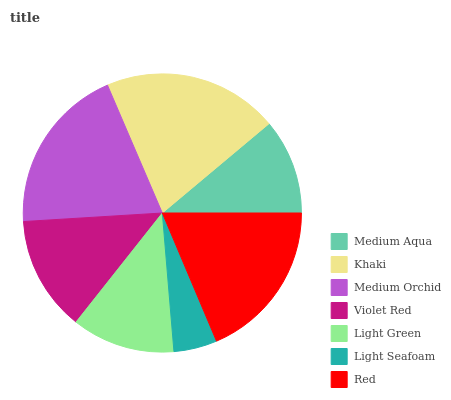Is Light Seafoam the minimum?
Answer yes or no. Yes. Is Khaki the maximum?
Answer yes or no. Yes. Is Medium Orchid the minimum?
Answer yes or no. No. Is Medium Orchid the maximum?
Answer yes or no. No. Is Khaki greater than Medium Orchid?
Answer yes or no. Yes. Is Medium Orchid less than Khaki?
Answer yes or no. Yes. Is Medium Orchid greater than Khaki?
Answer yes or no. No. Is Khaki less than Medium Orchid?
Answer yes or no. No. Is Violet Red the high median?
Answer yes or no. Yes. Is Violet Red the low median?
Answer yes or no. Yes. Is Light Green the high median?
Answer yes or no. No. Is Khaki the low median?
Answer yes or no. No. 